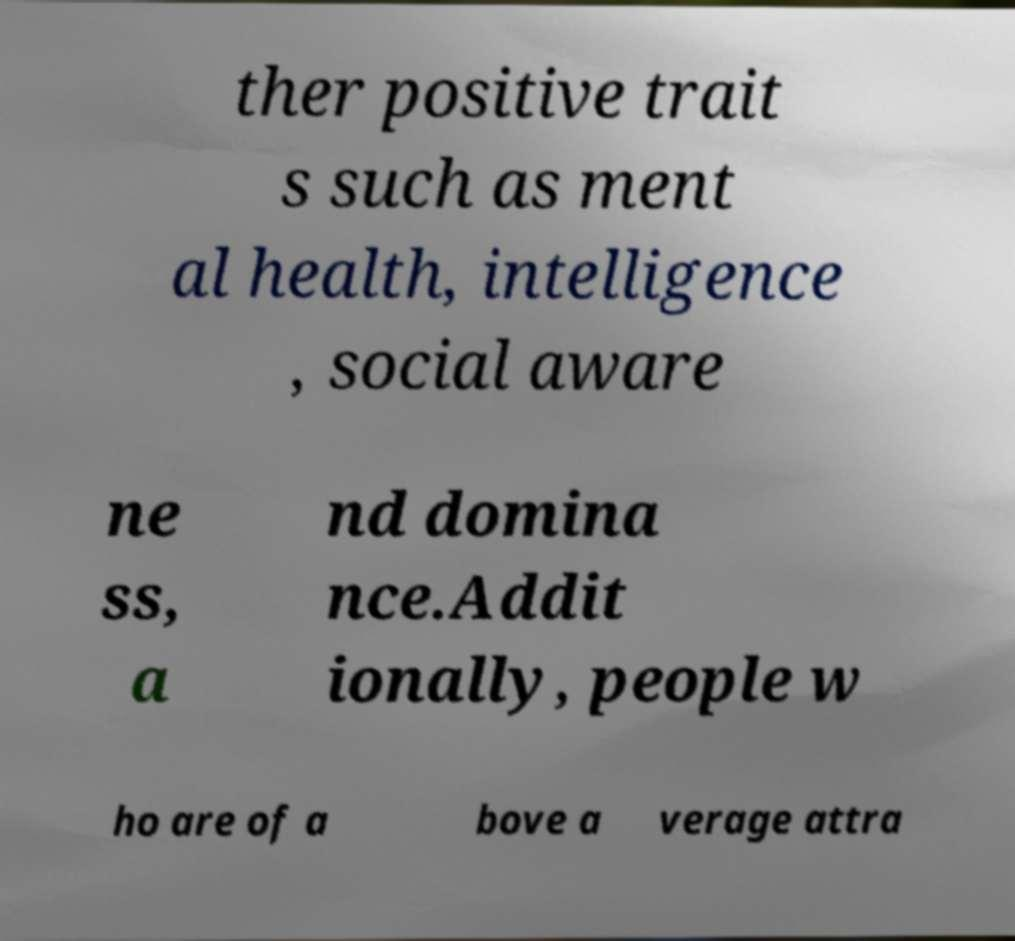Could you extract and type out the text from this image? ther positive trait s such as ment al health, intelligence , social aware ne ss, a nd domina nce.Addit ionally, people w ho are of a bove a verage attra 